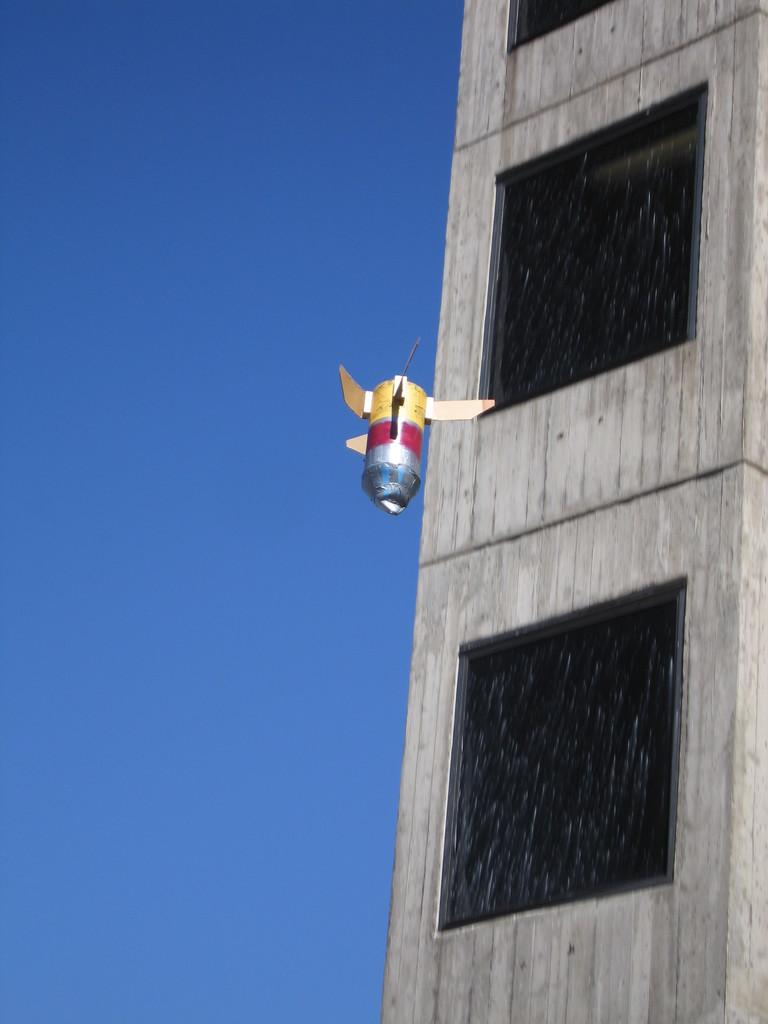What is flying in the air in the image? There is an object flying in the air in the image. What type of structure is visible in the image? There is a building with multiple windows in the image. What is the condition of the sky in the image? The sky is clear in the image. Can you see a tent in the image? There is no tent present in the image. How many cows are visible in the image? There are no cows present in the image. 